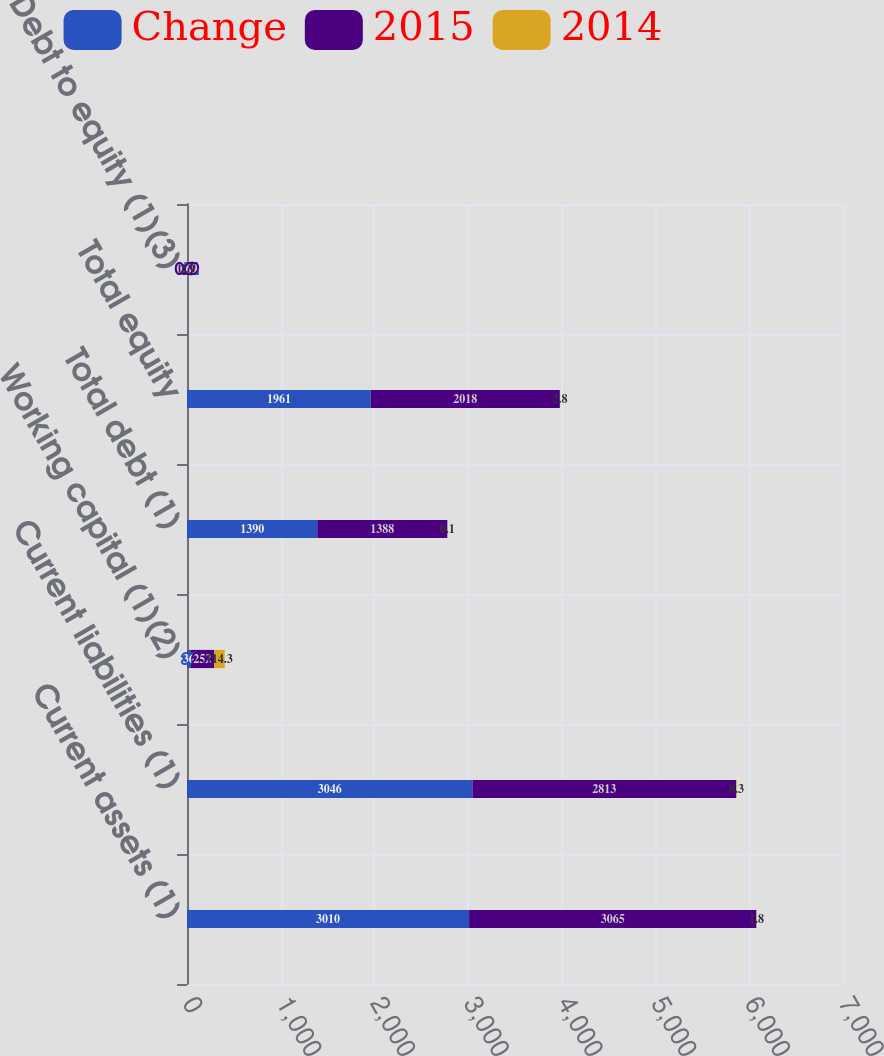Convert chart to OTSL. <chart><loc_0><loc_0><loc_500><loc_500><stacked_bar_chart><ecel><fcel>Current assets (1)<fcel>Current liabilities (1)<fcel>Working capital (1)(2)<fcel>Total debt (1)<fcel>Total equity<fcel>Debt to equity (1)(3)<nl><fcel>Change<fcel>3010<fcel>3046<fcel>36<fcel>1390<fcel>1961<fcel>0.71<nl><fcel>2015<fcel>3065<fcel>2813<fcel>252<fcel>1388<fcel>2018<fcel>0.69<nl><fcel>2014<fcel>1.8<fcel>8.3<fcel>114.3<fcel>0.1<fcel>2.8<fcel>2.9<nl></chart> 